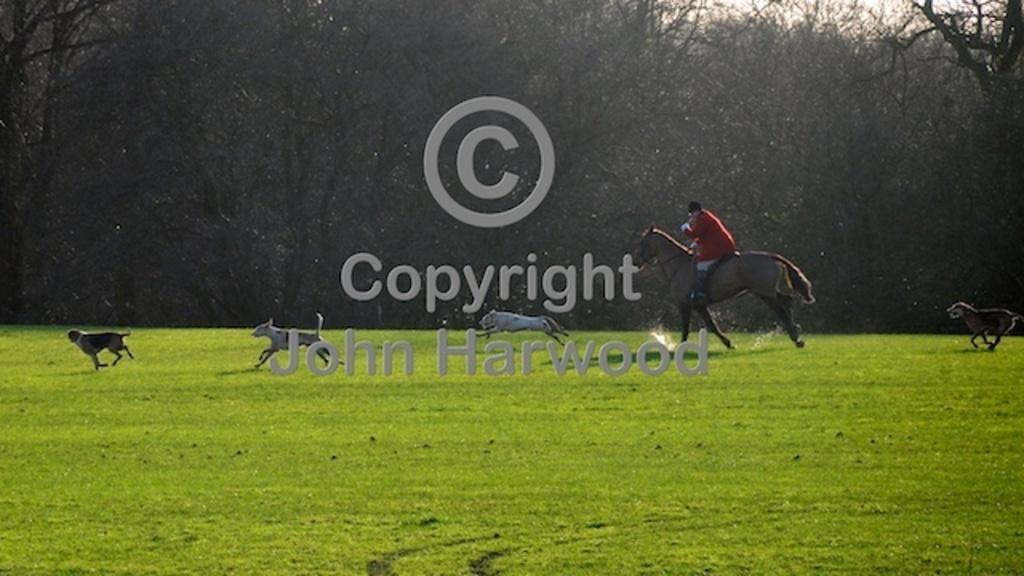Describe this image in one or two sentences. In the middle of this image, there is a watermark. In the background, there is a person riding a horse, there are dogs running on the grass on the ground, there are trees and there is sky. 